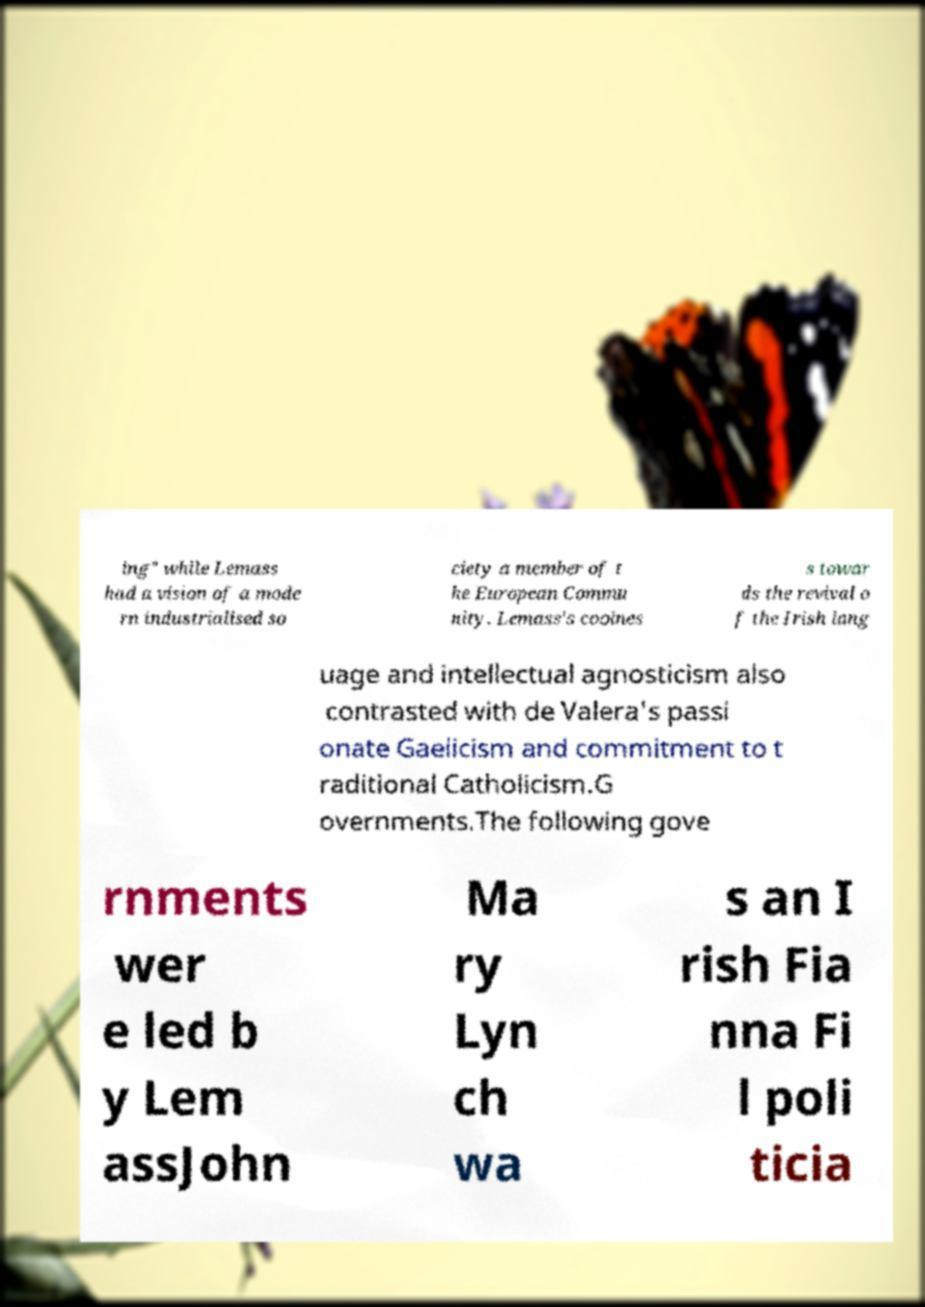Can you accurately transcribe the text from the provided image for me? ing" while Lemass had a vision of a mode rn industrialised so ciety a member of t he European Commu nity. Lemass's coolnes s towar ds the revival o f the Irish lang uage and intellectual agnosticism also contrasted with de Valera's passi onate Gaelicism and commitment to t raditional Catholicism.G overnments.The following gove rnments wer e led b y Lem assJohn Ma ry Lyn ch wa s an I rish Fia nna Fi l poli ticia 